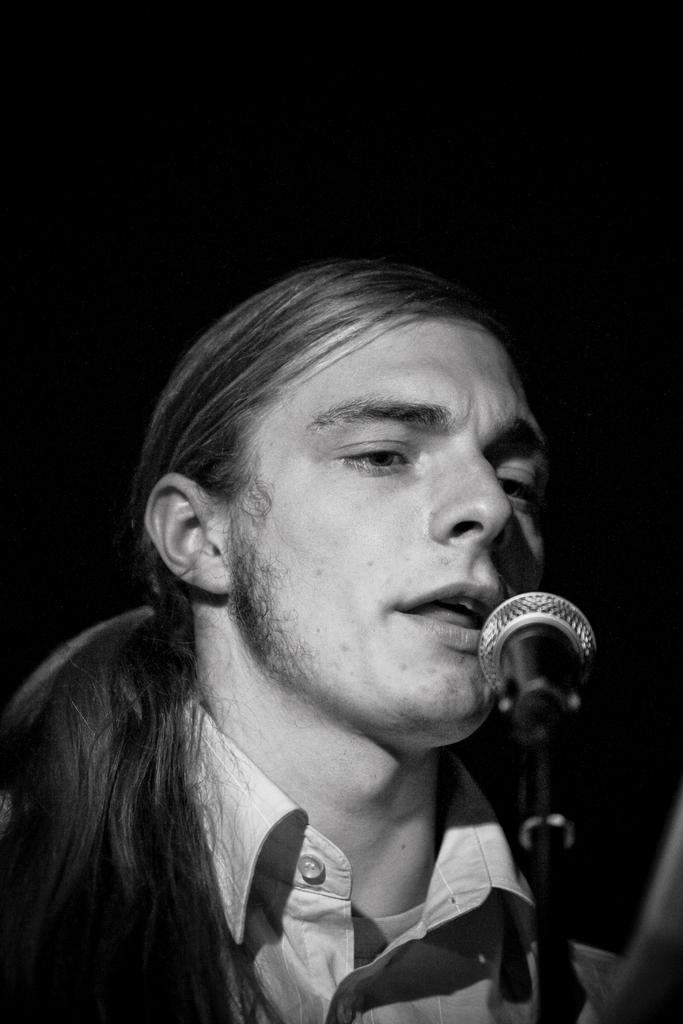What is the main subject of the image? There is a person in the image. What is the person doing in the image? The person is singing. What object is the person using while singing? The person is in front of a microphone. What is the color scheme of the image? The image is in black and white. How many clovers can be seen in the image? There are no clovers present in the image. What is the person's chin doing in the image? The person's chin is not mentioned in the image, so it cannot be determined what it is doing. 